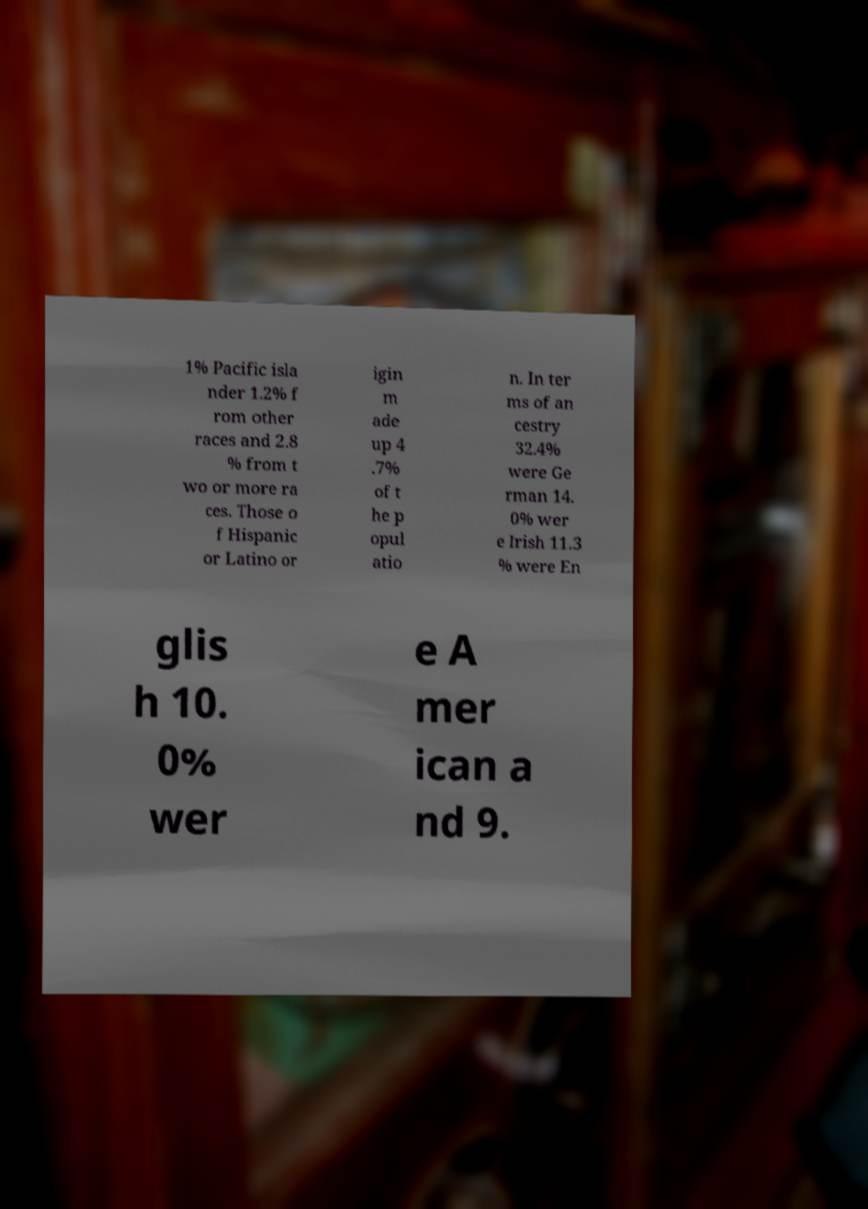I need the written content from this picture converted into text. Can you do that? 1% Pacific isla nder 1.2% f rom other races and 2.8 % from t wo or more ra ces. Those o f Hispanic or Latino or igin m ade up 4 .7% of t he p opul atio n. In ter ms of an cestry 32.4% were Ge rman 14. 0% wer e Irish 11.3 % were En glis h 10. 0% wer e A mer ican a nd 9. 